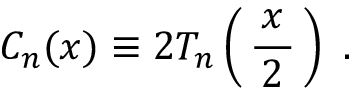Convert formula to latex. <formula><loc_0><loc_0><loc_500><loc_500>C _ { n } ( x ) \equiv 2 T _ { n } \left ( \, { \frac { \, x \, } { 2 } } \, \right ) .</formula> 